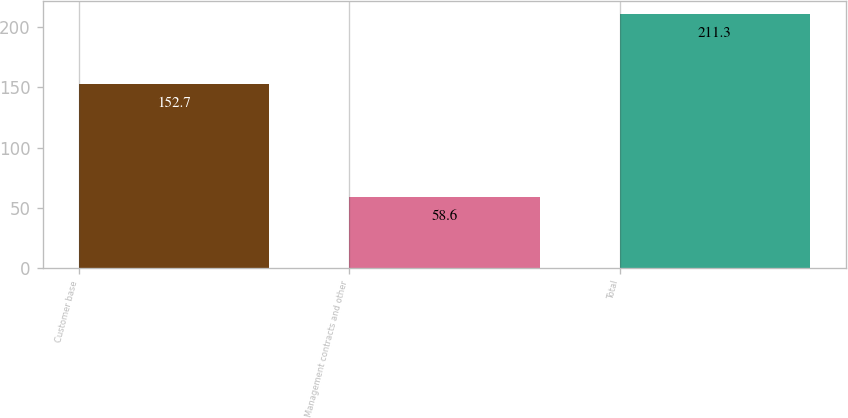Convert chart to OTSL. <chart><loc_0><loc_0><loc_500><loc_500><bar_chart><fcel>Customer base<fcel>Management contracts and other<fcel>Total<nl><fcel>152.7<fcel>58.6<fcel>211.3<nl></chart> 